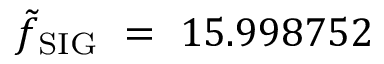Convert formula to latex. <formula><loc_0><loc_0><loc_500><loc_500>\tilde { f } _ { S I G } = 1 5 . 9 9 8 7 5 2</formula> 